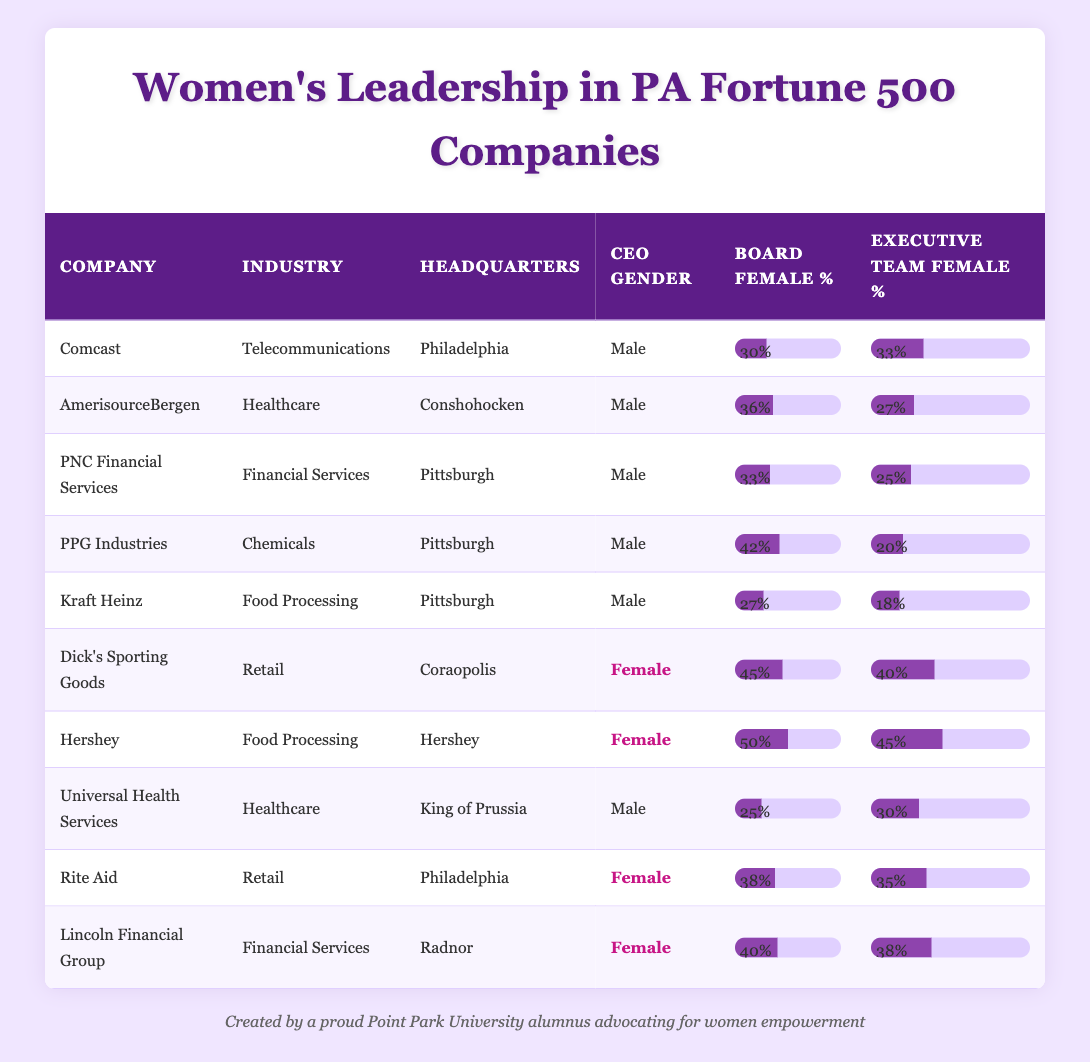What percentage of the executive team at Dick's Sporting Goods is female? According to the table, the executive team female percentage for Dick's Sporting Goods is shown as 40%.
Answer: 40% What is the highest board female percentage among the listed companies? From the table, Hershey has the highest board female percentage at 50%.
Answer: 50% Are there any companies with a female CEO that have a board female percentage below 40%? Checking the companies with female CEOs: Dick's Sporting Goods (45%), Hershey (50%), Rite Aid (38%), and Lincoln Financial Group (40%). Rite Aid has a board female percentage of 38%, which is below 40%, making the statement true.
Answer: Yes What is the average board female percentage of companies with male CEOs? Examine the companies with male CEOs: Comcast (30%), AmerisourceBergen (36%), PNC Financial Services (33%), PPG Industries (42%), Kraft Heinz (27%), and Universal Health Services (25%). Summing these gives 30 + 36 + 33 + 42 + 27 + 25 = 193. There are 6 companies, so the average is 193/6 ≈ 32.17%.
Answer: 32.17% Is Rite Aid the only company with a female CEO located in Philadelphia? From the table, Rite Aid is indeed listed as having a female CEO and is located in Philadelphia, and we verify that there are no other companies with female CEOs in that city listed. Therefore, the statement is true.
Answer: Yes What is the difference in percentage between the board female percentage of Kraft Heinz and PPG Industries? The board female percentage for Kraft Heinz is 27% and for PPG Industries, it is 42%. The difference can be calculated as 42 - 27 = 15%.
Answer: 15% Which company has the lowest executive team female percentage and what is that percentage? Looking through the table, Kraft Heinz has the lowest executive team female percentage at 18%.
Answer: 18% What percentage of the board of Lincoln Financial Group is female? The table states that the board female percentage for Lincoln Financial Group is 40%.
Answer: 40% How many companies in the table have a board female percentage equal to or above 40%? The companies with a board female percentage of at least 40% are Hershey (50%), Dick's Sporting Goods (45%), Lincoln Financial Group (40%), and PPG Industries (42%). This is a total of 4 companies.
Answer: 4 